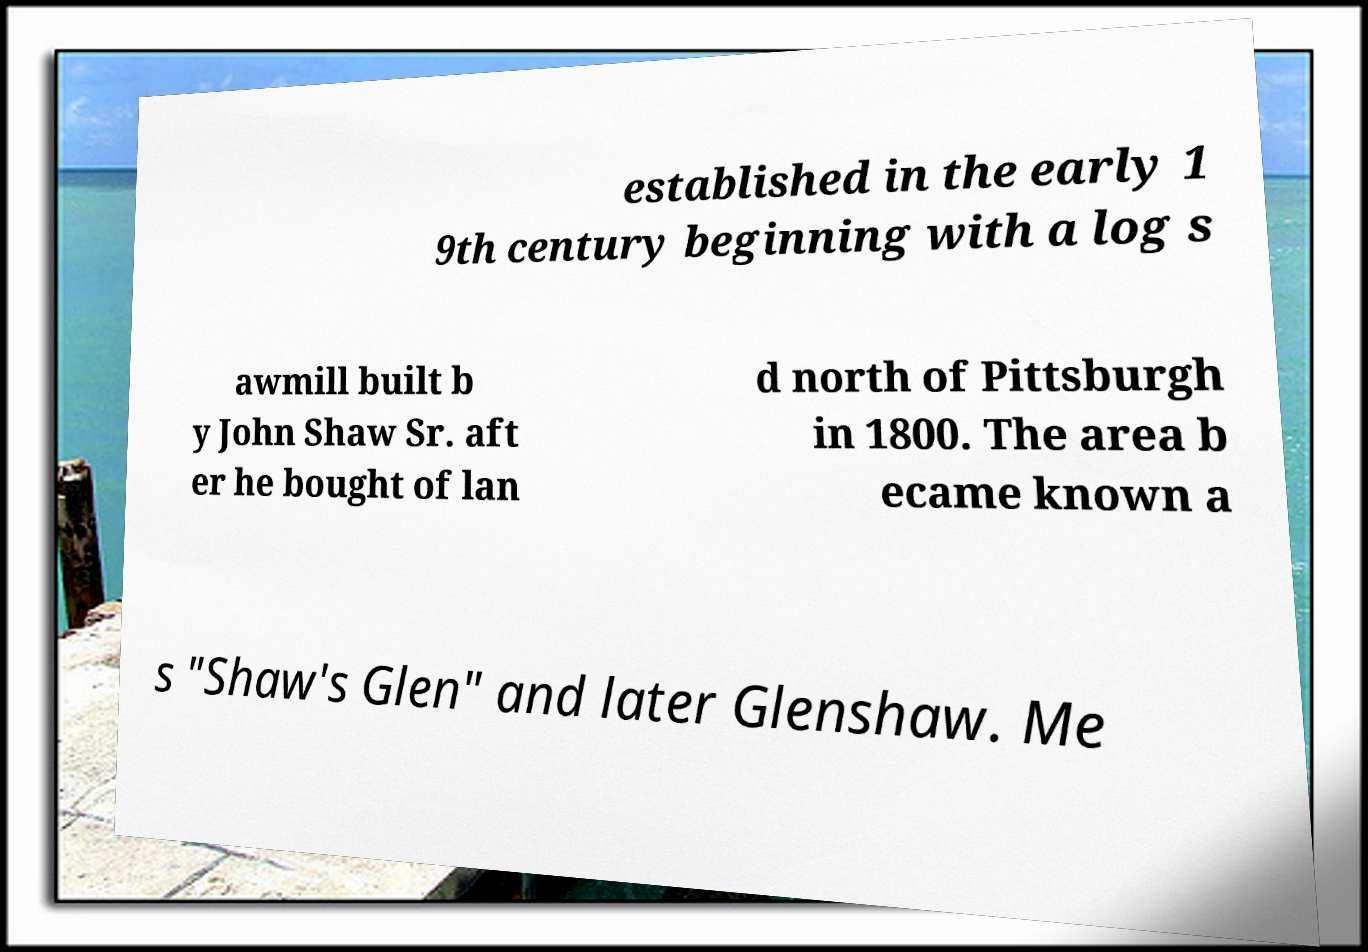Can you accurately transcribe the text from the provided image for me? established in the early 1 9th century beginning with a log s awmill built b y John Shaw Sr. aft er he bought of lan d north of Pittsburgh in 1800. The area b ecame known a s "Shaw's Glen" and later Glenshaw. Me 